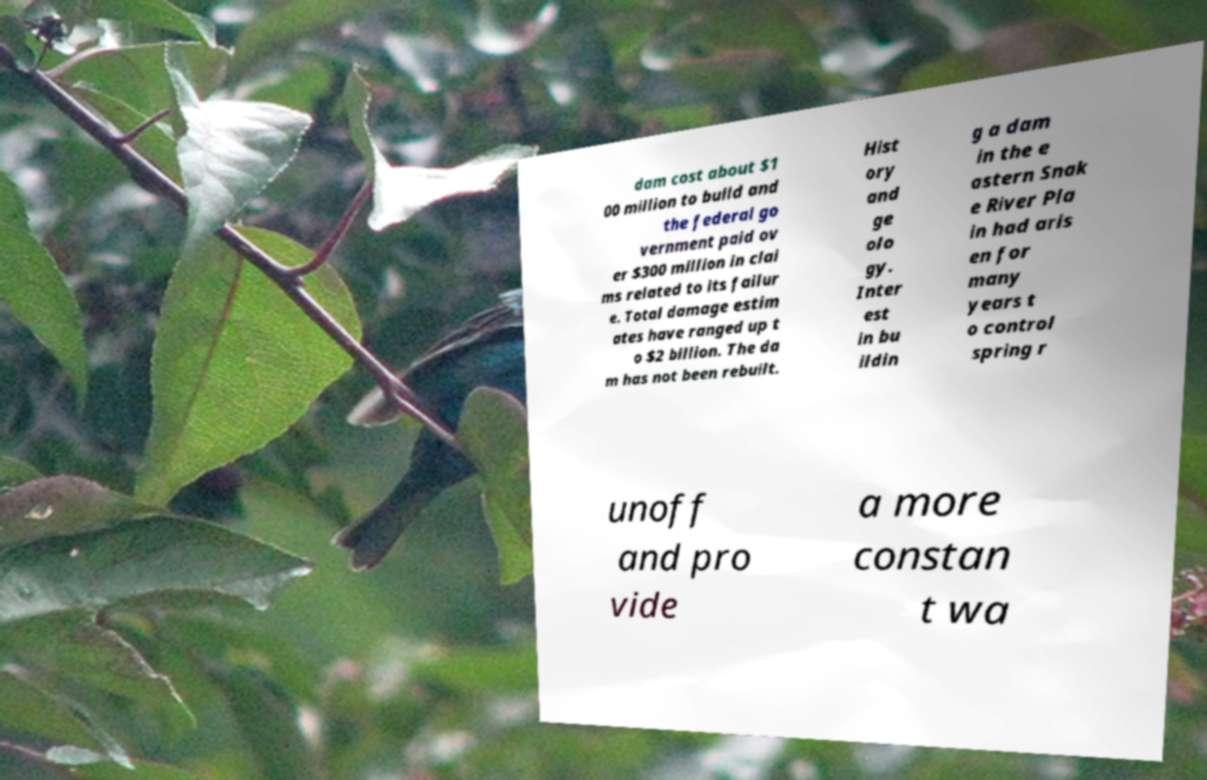Can you accurately transcribe the text from the provided image for me? dam cost about $1 00 million to build and the federal go vernment paid ov er $300 million in clai ms related to its failur e. Total damage estim ates have ranged up t o $2 billion. The da m has not been rebuilt. Hist ory and ge olo gy. Inter est in bu ildin g a dam in the e astern Snak e River Pla in had aris en for many years t o control spring r unoff and pro vide a more constan t wa 